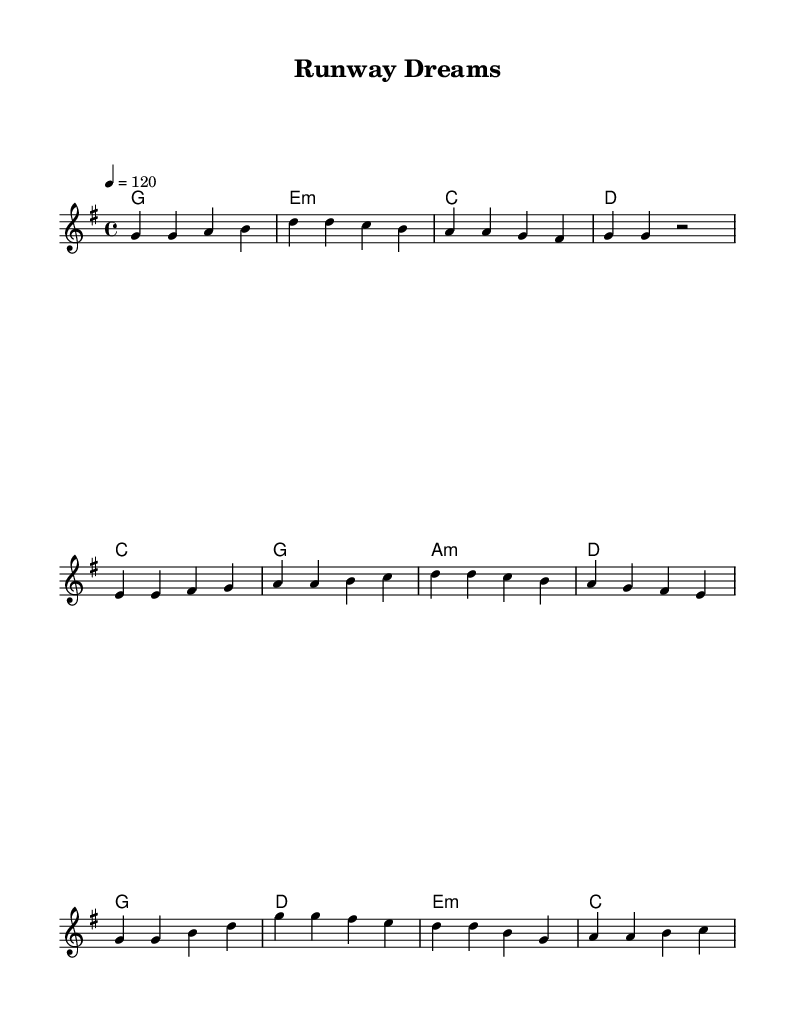What is the key signature of this music? The key signature is G major, which has one sharp (F#).
Answer: G major What is the time signature of the piece? The time signature is 4/4, indicating four beats per measure.
Answer: 4/4 What is the tempo of the music? The tempo indicates that the piece should be played at 120 beats per minute (quarter note).
Answer: 120 How many measures are in the verse? There are four measures in the verse based on the repeated sections in the melody.
Answer: 4 What is the chord progression for the pre-chorus? The chord progression is C, G, A minor, and D, as indicated in the harmony section.
Answer: C, G, A minor, D What is the highest note in the melody? The highest note in the melody is B, which is reached in the pre-chorus and the chorus sections.
Answer: B What is the overall structure of the song? The song consists of a verse, a pre-chorus, and a chorus, making up a common pop song structure.
Answer: Verse, Pre-chorus, Chorus 